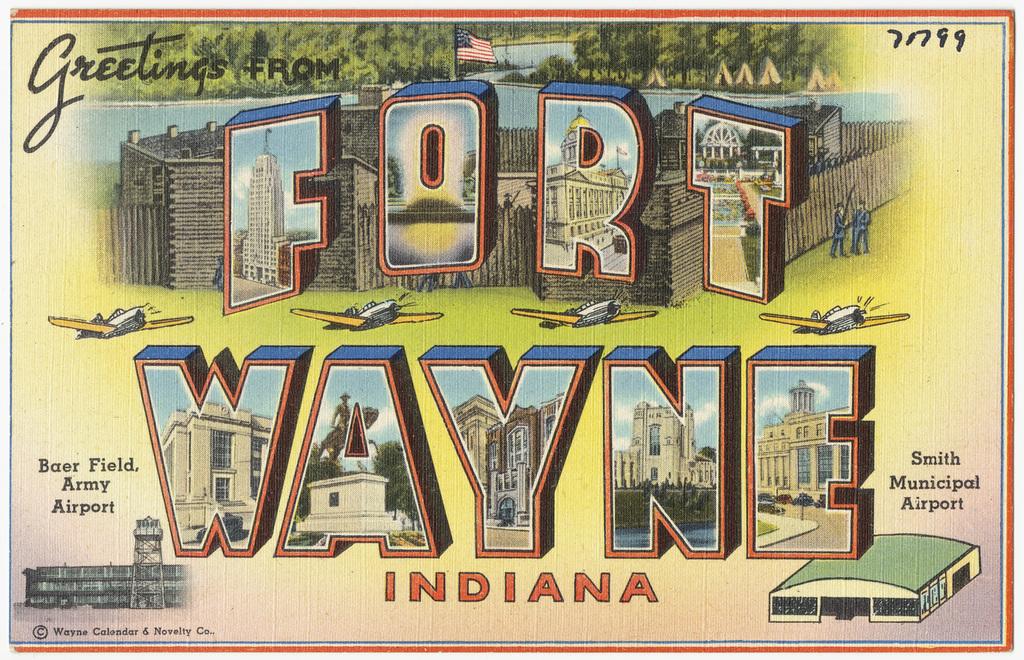Where did this postcard come from?
Provide a short and direct response. Fort wayne indiana. What is the name of the airport?
Provide a succinct answer. Smith municipal airport. 